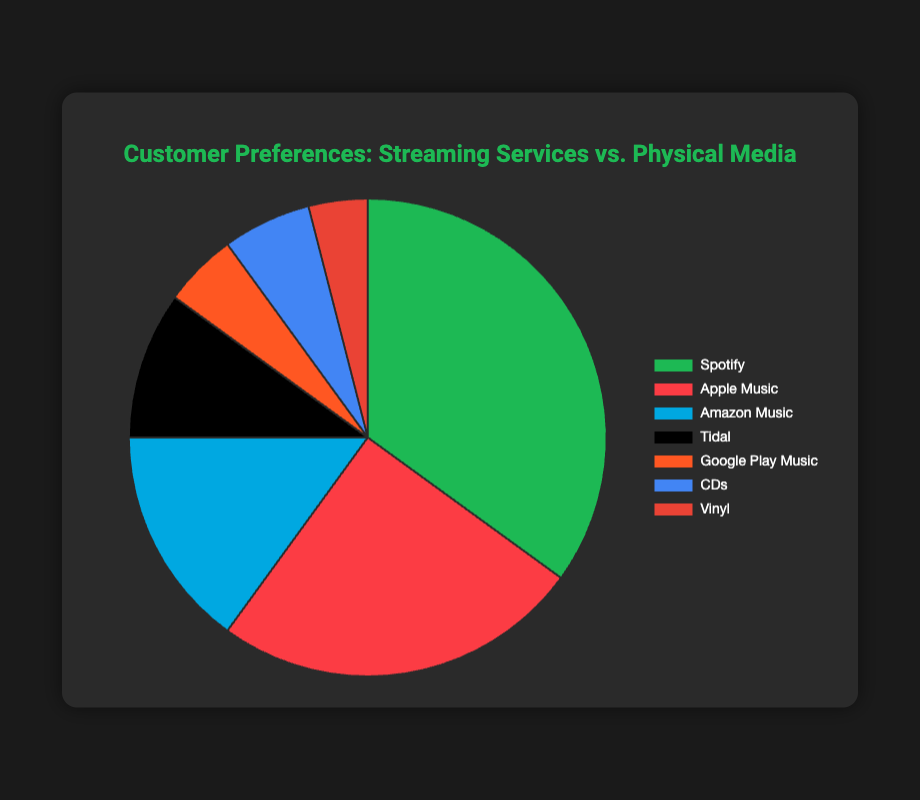Which streaming service has the highest customer preference? The biggest section of the pie chart represents Spotify, which has the highest percentage among the options.
Answer: Spotify How much larger is Spotify's share compared to Apple Music's? The pie chart shows Spotify at 35% and Apple Music at 25%. The difference is calculated by subtracting 25 from 35, resulting in 10%.
Answer: 10% What percentage of people prefer physical media purchases (both CDs and Vinyl)? Add the percentage of Physical Media Purchases - CDs (6%) and Physical Media Purchases - Vinyl (4%). So, 6 + 4 = 10%.
Answer: 10% Which physical media format has a higher preference? Physical Media Purchases - CDs have a higher percentage (6%) compared to Physical Media Purchases - Vinyl (4%).
Answer: CDs Among the streaming services, which one has the least customer preference? The smallest segment among the streaming services is Google Play Music, which has 5% according to the pie chart.
Answer: Google Play Music What is the combined percentage of the top three streaming services? The top three streaming services are Spotify (35%), Apple Music (25%), and Amazon Music (15%). Adding these percentages gives 35 + 25 + 15 = 75%.
Answer: 75% How does Tidal's preference compare to Google Play Music's? Tidal has 10% preference while Google Play Music has 5%. Therefore, Tidal's preference is double that of Google Play Music.
Answer: Double What fraction of the total preferences is for Apple Music? Apple Music accounts for 25% of the total. This can be expressed as a fraction by writing it as 25/100, which simplifies to 1/4.
Answer: 1/4 Is the combined preference for streaming services more than 80%? Summing up the percentages for all streaming services: Spotify (35%), Apple Music (25%), Amazon Music (15%), Tidal (10%), and Google Play Music (5%) results in 35 + 25 + 15 + 10 + 5 = 90%, which is more than 80%.
Answer: Yes, it is more than 80% What color is used to represent Amazon Music in the chart? The segment representing Amazon Music is colored blue.
Answer: Blue 